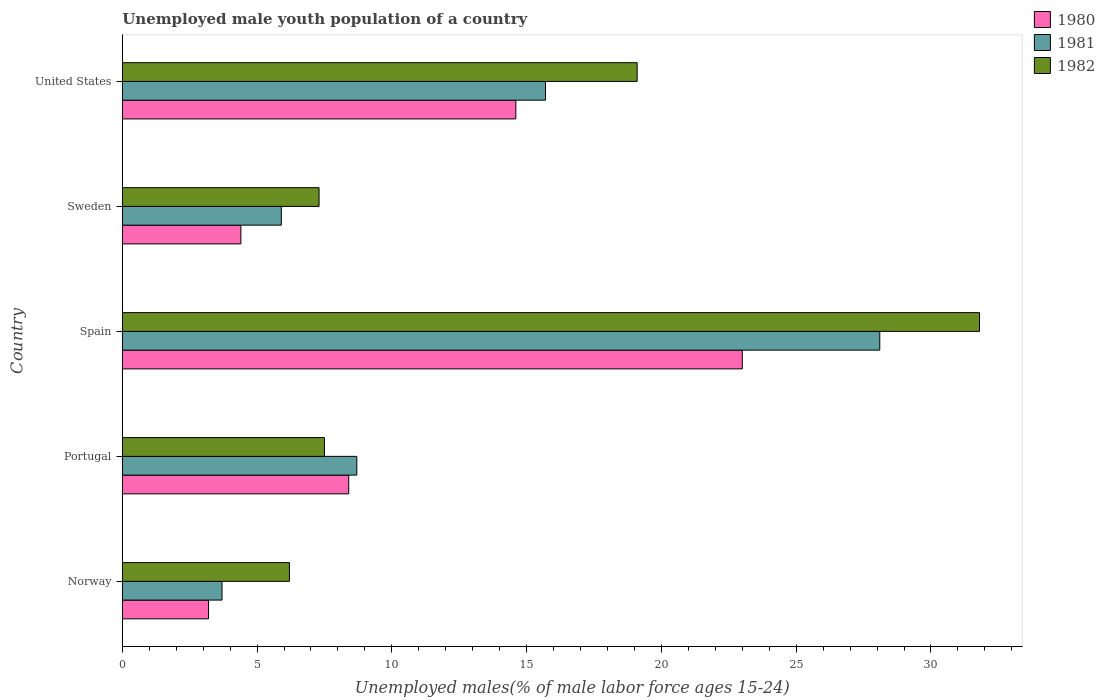How many different coloured bars are there?
Provide a succinct answer. 3. Are the number of bars per tick equal to the number of legend labels?
Make the answer very short. Yes. What is the label of the 3rd group of bars from the top?
Provide a succinct answer. Spain. In how many cases, is the number of bars for a given country not equal to the number of legend labels?
Provide a short and direct response. 0. Across all countries, what is the maximum percentage of unemployed male youth population in 1981?
Offer a terse response. 28.1. Across all countries, what is the minimum percentage of unemployed male youth population in 1980?
Offer a very short reply. 3.2. In which country was the percentage of unemployed male youth population in 1982 minimum?
Keep it short and to the point. Norway. What is the total percentage of unemployed male youth population in 1982 in the graph?
Provide a succinct answer. 71.9. What is the difference between the percentage of unemployed male youth population in 1982 in Sweden and that in United States?
Provide a short and direct response. -11.8. What is the difference between the percentage of unemployed male youth population in 1980 in Norway and the percentage of unemployed male youth population in 1982 in Sweden?
Make the answer very short. -4.1. What is the average percentage of unemployed male youth population in 1981 per country?
Give a very brief answer. 12.42. What is the difference between the percentage of unemployed male youth population in 1980 and percentage of unemployed male youth population in 1981 in Sweden?
Provide a succinct answer. -1.5. What is the ratio of the percentage of unemployed male youth population in 1981 in Norway to that in Sweden?
Your answer should be very brief. 0.63. Is the percentage of unemployed male youth population in 1982 in Norway less than that in Spain?
Offer a terse response. Yes. Is the difference between the percentage of unemployed male youth population in 1980 in Spain and Sweden greater than the difference between the percentage of unemployed male youth population in 1981 in Spain and Sweden?
Give a very brief answer. No. What is the difference between the highest and the second highest percentage of unemployed male youth population in 1980?
Offer a very short reply. 8.4. What is the difference between the highest and the lowest percentage of unemployed male youth population in 1980?
Offer a terse response. 19.8. Is the sum of the percentage of unemployed male youth population in 1980 in Spain and Sweden greater than the maximum percentage of unemployed male youth population in 1981 across all countries?
Offer a very short reply. No. What is the difference between two consecutive major ticks on the X-axis?
Your response must be concise. 5. Are the values on the major ticks of X-axis written in scientific E-notation?
Your answer should be compact. No. Does the graph contain any zero values?
Make the answer very short. No. Does the graph contain grids?
Your response must be concise. No. How many legend labels are there?
Keep it short and to the point. 3. What is the title of the graph?
Offer a very short reply. Unemployed male youth population of a country. What is the label or title of the X-axis?
Make the answer very short. Unemployed males(% of male labor force ages 15-24). What is the label or title of the Y-axis?
Your response must be concise. Country. What is the Unemployed males(% of male labor force ages 15-24) in 1980 in Norway?
Offer a very short reply. 3.2. What is the Unemployed males(% of male labor force ages 15-24) in 1981 in Norway?
Ensure brevity in your answer.  3.7. What is the Unemployed males(% of male labor force ages 15-24) in 1982 in Norway?
Ensure brevity in your answer.  6.2. What is the Unemployed males(% of male labor force ages 15-24) in 1980 in Portugal?
Your answer should be very brief. 8.4. What is the Unemployed males(% of male labor force ages 15-24) of 1981 in Portugal?
Provide a short and direct response. 8.7. What is the Unemployed males(% of male labor force ages 15-24) in 1982 in Portugal?
Ensure brevity in your answer.  7.5. What is the Unemployed males(% of male labor force ages 15-24) of 1981 in Spain?
Your answer should be compact. 28.1. What is the Unemployed males(% of male labor force ages 15-24) of 1982 in Spain?
Your answer should be very brief. 31.8. What is the Unemployed males(% of male labor force ages 15-24) of 1980 in Sweden?
Offer a very short reply. 4.4. What is the Unemployed males(% of male labor force ages 15-24) of 1981 in Sweden?
Keep it short and to the point. 5.9. What is the Unemployed males(% of male labor force ages 15-24) in 1982 in Sweden?
Make the answer very short. 7.3. What is the Unemployed males(% of male labor force ages 15-24) in 1980 in United States?
Provide a short and direct response. 14.6. What is the Unemployed males(% of male labor force ages 15-24) of 1981 in United States?
Your answer should be very brief. 15.7. What is the Unemployed males(% of male labor force ages 15-24) in 1982 in United States?
Provide a succinct answer. 19.1. Across all countries, what is the maximum Unemployed males(% of male labor force ages 15-24) in 1981?
Your response must be concise. 28.1. Across all countries, what is the maximum Unemployed males(% of male labor force ages 15-24) of 1982?
Your answer should be very brief. 31.8. Across all countries, what is the minimum Unemployed males(% of male labor force ages 15-24) in 1980?
Offer a very short reply. 3.2. Across all countries, what is the minimum Unemployed males(% of male labor force ages 15-24) of 1981?
Give a very brief answer. 3.7. Across all countries, what is the minimum Unemployed males(% of male labor force ages 15-24) of 1982?
Make the answer very short. 6.2. What is the total Unemployed males(% of male labor force ages 15-24) of 1980 in the graph?
Your answer should be compact. 53.6. What is the total Unemployed males(% of male labor force ages 15-24) in 1981 in the graph?
Make the answer very short. 62.1. What is the total Unemployed males(% of male labor force ages 15-24) in 1982 in the graph?
Offer a very short reply. 71.9. What is the difference between the Unemployed males(% of male labor force ages 15-24) in 1981 in Norway and that in Portugal?
Keep it short and to the point. -5. What is the difference between the Unemployed males(% of male labor force ages 15-24) of 1980 in Norway and that in Spain?
Ensure brevity in your answer.  -19.8. What is the difference between the Unemployed males(% of male labor force ages 15-24) of 1981 in Norway and that in Spain?
Keep it short and to the point. -24.4. What is the difference between the Unemployed males(% of male labor force ages 15-24) in 1982 in Norway and that in Spain?
Give a very brief answer. -25.6. What is the difference between the Unemployed males(% of male labor force ages 15-24) in 1981 in Norway and that in Sweden?
Offer a terse response. -2.2. What is the difference between the Unemployed males(% of male labor force ages 15-24) of 1982 in Norway and that in Sweden?
Give a very brief answer. -1.1. What is the difference between the Unemployed males(% of male labor force ages 15-24) in 1980 in Portugal and that in Spain?
Offer a very short reply. -14.6. What is the difference between the Unemployed males(% of male labor force ages 15-24) in 1981 in Portugal and that in Spain?
Provide a succinct answer. -19.4. What is the difference between the Unemployed males(% of male labor force ages 15-24) in 1982 in Portugal and that in Spain?
Your response must be concise. -24.3. What is the difference between the Unemployed males(% of male labor force ages 15-24) of 1982 in Portugal and that in Sweden?
Give a very brief answer. 0.2. What is the difference between the Unemployed males(% of male labor force ages 15-24) of 1982 in Portugal and that in United States?
Keep it short and to the point. -11.6. What is the difference between the Unemployed males(% of male labor force ages 15-24) of 1981 in Spain and that in Sweden?
Offer a very short reply. 22.2. What is the difference between the Unemployed males(% of male labor force ages 15-24) in 1980 in Spain and that in United States?
Your answer should be very brief. 8.4. What is the difference between the Unemployed males(% of male labor force ages 15-24) in 1982 in Spain and that in United States?
Your response must be concise. 12.7. What is the difference between the Unemployed males(% of male labor force ages 15-24) of 1980 in Sweden and that in United States?
Provide a succinct answer. -10.2. What is the difference between the Unemployed males(% of male labor force ages 15-24) in 1981 in Norway and the Unemployed males(% of male labor force ages 15-24) in 1982 in Portugal?
Make the answer very short. -3.8. What is the difference between the Unemployed males(% of male labor force ages 15-24) of 1980 in Norway and the Unemployed males(% of male labor force ages 15-24) of 1981 in Spain?
Give a very brief answer. -24.9. What is the difference between the Unemployed males(% of male labor force ages 15-24) in 1980 in Norway and the Unemployed males(% of male labor force ages 15-24) in 1982 in Spain?
Your answer should be very brief. -28.6. What is the difference between the Unemployed males(% of male labor force ages 15-24) of 1981 in Norway and the Unemployed males(% of male labor force ages 15-24) of 1982 in Spain?
Your answer should be very brief. -28.1. What is the difference between the Unemployed males(% of male labor force ages 15-24) of 1981 in Norway and the Unemployed males(% of male labor force ages 15-24) of 1982 in Sweden?
Ensure brevity in your answer.  -3.6. What is the difference between the Unemployed males(% of male labor force ages 15-24) in 1980 in Norway and the Unemployed males(% of male labor force ages 15-24) in 1982 in United States?
Keep it short and to the point. -15.9. What is the difference between the Unemployed males(% of male labor force ages 15-24) in 1981 in Norway and the Unemployed males(% of male labor force ages 15-24) in 1982 in United States?
Provide a succinct answer. -15.4. What is the difference between the Unemployed males(% of male labor force ages 15-24) of 1980 in Portugal and the Unemployed males(% of male labor force ages 15-24) of 1981 in Spain?
Offer a very short reply. -19.7. What is the difference between the Unemployed males(% of male labor force ages 15-24) in 1980 in Portugal and the Unemployed males(% of male labor force ages 15-24) in 1982 in Spain?
Provide a succinct answer. -23.4. What is the difference between the Unemployed males(% of male labor force ages 15-24) of 1981 in Portugal and the Unemployed males(% of male labor force ages 15-24) of 1982 in Spain?
Offer a very short reply. -23.1. What is the difference between the Unemployed males(% of male labor force ages 15-24) in 1980 in Portugal and the Unemployed males(% of male labor force ages 15-24) in 1981 in Sweden?
Keep it short and to the point. 2.5. What is the difference between the Unemployed males(% of male labor force ages 15-24) in 1980 in Portugal and the Unemployed males(% of male labor force ages 15-24) in 1982 in Sweden?
Keep it short and to the point. 1.1. What is the difference between the Unemployed males(% of male labor force ages 15-24) in 1981 in Portugal and the Unemployed males(% of male labor force ages 15-24) in 1982 in Sweden?
Your answer should be very brief. 1.4. What is the difference between the Unemployed males(% of male labor force ages 15-24) in 1980 in Portugal and the Unemployed males(% of male labor force ages 15-24) in 1981 in United States?
Ensure brevity in your answer.  -7.3. What is the difference between the Unemployed males(% of male labor force ages 15-24) in 1980 in Spain and the Unemployed males(% of male labor force ages 15-24) in 1981 in Sweden?
Your response must be concise. 17.1. What is the difference between the Unemployed males(% of male labor force ages 15-24) of 1980 in Spain and the Unemployed males(% of male labor force ages 15-24) of 1982 in Sweden?
Provide a short and direct response. 15.7. What is the difference between the Unemployed males(% of male labor force ages 15-24) in 1981 in Spain and the Unemployed males(% of male labor force ages 15-24) in 1982 in Sweden?
Provide a short and direct response. 20.8. What is the difference between the Unemployed males(% of male labor force ages 15-24) in 1980 in Sweden and the Unemployed males(% of male labor force ages 15-24) in 1982 in United States?
Give a very brief answer. -14.7. What is the average Unemployed males(% of male labor force ages 15-24) of 1980 per country?
Ensure brevity in your answer.  10.72. What is the average Unemployed males(% of male labor force ages 15-24) in 1981 per country?
Your answer should be compact. 12.42. What is the average Unemployed males(% of male labor force ages 15-24) in 1982 per country?
Provide a succinct answer. 14.38. What is the difference between the Unemployed males(% of male labor force ages 15-24) in 1980 and Unemployed males(% of male labor force ages 15-24) in 1981 in Norway?
Provide a short and direct response. -0.5. What is the difference between the Unemployed males(% of male labor force ages 15-24) of 1981 and Unemployed males(% of male labor force ages 15-24) of 1982 in Norway?
Offer a terse response. -2.5. What is the difference between the Unemployed males(% of male labor force ages 15-24) in 1980 and Unemployed males(% of male labor force ages 15-24) in 1981 in Portugal?
Ensure brevity in your answer.  -0.3. What is the difference between the Unemployed males(% of male labor force ages 15-24) in 1981 and Unemployed males(% of male labor force ages 15-24) in 1982 in Spain?
Ensure brevity in your answer.  -3.7. What is the difference between the Unemployed males(% of male labor force ages 15-24) of 1980 and Unemployed males(% of male labor force ages 15-24) of 1981 in Sweden?
Provide a succinct answer. -1.5. What is the difference between the Unemployed males(% of male labor force ages 15-24) in 1980 and Unemployed males(% of male labor force ages 15-24) in 1981 in United States?
Give a very brief answer. -1.1. What is the difference between the Unemployed males(% of male labor force ages 15-24) of 1980 and Unemployed males(% of male labor force ages 15-24) of 1982 in United States?
Ensure brevity in your answer.  -4.5. What is the ratio of the Unemployed males(% of male labor force ages 15-24) in 1980 in Norway to that in Portugal?
Make the answer very short. 0.38. What is the ratio of the Unemployed males(% of male labor force ages 15-24) in 1981 in Norway to that in Portugal?
Offer a very short reply. 0.43. What is the ratio of the Unemployed males(% of male labor force ages 15-24) of 1982 in Norway to that in Portugal?
Make the answer very short. 0.83. What is the ratio of the Unemployed males(% of male labor force ages 15-24) in 1980 in Norway to that in Spain?
Make the answer very short. 0.14. What is the ratio of the Unemployed males(% of male labor force ages 15-24) of 1981 in Norway to that in Spain?
Keep it short and to the point. 0.13. What is the ratio of the Unemployed males(% of male labor force ages 15-24) in 1982 in Norway to that in Spain?
Your response must be concise. 0.2. What is the ratio of the Unemployed males(% of male labor force ages 15-24) of 1980 in Norway to that in Sweden?
Your response must be concise. 0.73. What is the ratio of the Unemployed males(% of male labor force ages 15-24) in 1981 in Norway to that in Sweden?
Offer a terse response. 0.63. What is the ratio of the Unemployed males(% of male labor force ages 15-24) in 1982 in Norway to that in Sweden?
Ensure brevity in your answer.  0.85. What is the ratio of the Unemployed males(% of male labor force ages 15-24) of 1980 in Norway to that in United States?
Your answer should be very brief. 0.22. What is the ratio of the Unemployed males(% of male labor force ages 15-24) in 1981 in Norway to that in United States?
Keep it short and to the point. 0.24. What is the ratio of the Unemployed males(% of male labor force ages 15-24) in 1982 in Norway to that in United States?
Your response must be concise. 0.32. What is the ratio of the Unemployed males(% of male labor force ages 15-24) in 1980 in Portugal to that in Spain?
Your answer should be compact. 0.37. What is the ratio of the Unemployed males(% of male labor force ages 15-24) of 1981 in Portugal to that in Spain?
Ensure brevity in your answer.  0.31. What is the ratio of the Unemployed males(% of male labor force ages 15-24) of 1982 in Portugal to that in Spain?
Keep it short and to the point. 0.24. What is the ratio of the Unemployed males(% of male labor force ages 15-24) of 1980 in Portugal to that in Sweden?
Offer a terse response. 1.91. What is the ratio of the Unemployed males(% of male labor force ages 15-24) in 1981 in Portugal to that in Sweden?
Make the answer very short. 1.47. What is the ratio of the Unemployed males(% of male labor force ages 15-24) of 1982 in Portugal to that in Sweden?
Give a very brief answer. 1.03. What is the ratio of the Unemployed males(% of male labor force ages 15-24) in 1980 in Portugal to that in United States?
Give a very brief answer. 0.58. What is the ratio of the Unemployed males(% of male labor force ages 15-24) in 1981 in Portugal to that in United States?
Offer a very short reply. 0.55. What is the ratio of the Unemployed males(% of male labor force ages 15-24) of 1982 in Portugal to that in United States?
Provide a succinct answer. 0.39. What is the ratio of the Unemployed males(% of male labor force ages 15-24) in 1980 in Spain to that in Sweden?
Provide a succinct answer. 5.23. What is the ratio of the Unemployed males(% of male labor force ages 15-24) in 1981 in Spain to that in Sweden?
Give a very brief answer. 4.76. What is the ratio of the Unemployed males(% of male labor force ages 15-24) in 1982 in Spain to that in Sweden?
Provide a succinct answer. 4.36. What is the ratio of the Unemployed males(% of male labor force ages 15-24) of 1980 in Spain to that in United States?
Your answer should be very brief. 1.58. What is the ratio of the Unemployed males(% of male labor force ages 15-24) of 1981 in Spain to that in United States?
Your answer should be compact. 1.79. What is the ratio of the Unemployed males(% of male labor force ages 15-24) of 1982 in Spain to that in United States?
Provide a short and direct response. 1.66. What is the ratio of the Unemployed males(% of male labor force ages 15-24) in 1980 in Sweden to that in United States?
Offer a terse response. 0.3. What is the ratio of the Unemployed males(% of male labor force ages 15-24) of 1981 in Sweden to that in United States?
Your answer should be compact. 0.38. What is the ratio of the Unemployed males(% of male labor force ages 15-24) in 1982 in Sweden to that in United States?
Offer a terse response. 0.38. What is the difference between the highest and the second highest Unemployed males(% of male labor force ages 15-24) in 1980?
Offer a terse response. 8.4. What is the difference between the highest and the second highest Unemployed males(% of male labor force ages 15-24) of 1981?
Make the answer very short. 12.4. What is the difference between the highest and the lowest Unemployed males(% of male labor force ages 15-24) in 1980?
Provide a succinct answer. 19.8. What is the difference between the highest and the lowest Unemployed males(% of male labor force ages 15-24) of 1981?
Ensure brevity in your answer.  24.4. What is the difference between the highest and the lowest Unemployed males(% of male labor force ages 15-24) of 1982?
Offer a terse response. 25.6. 